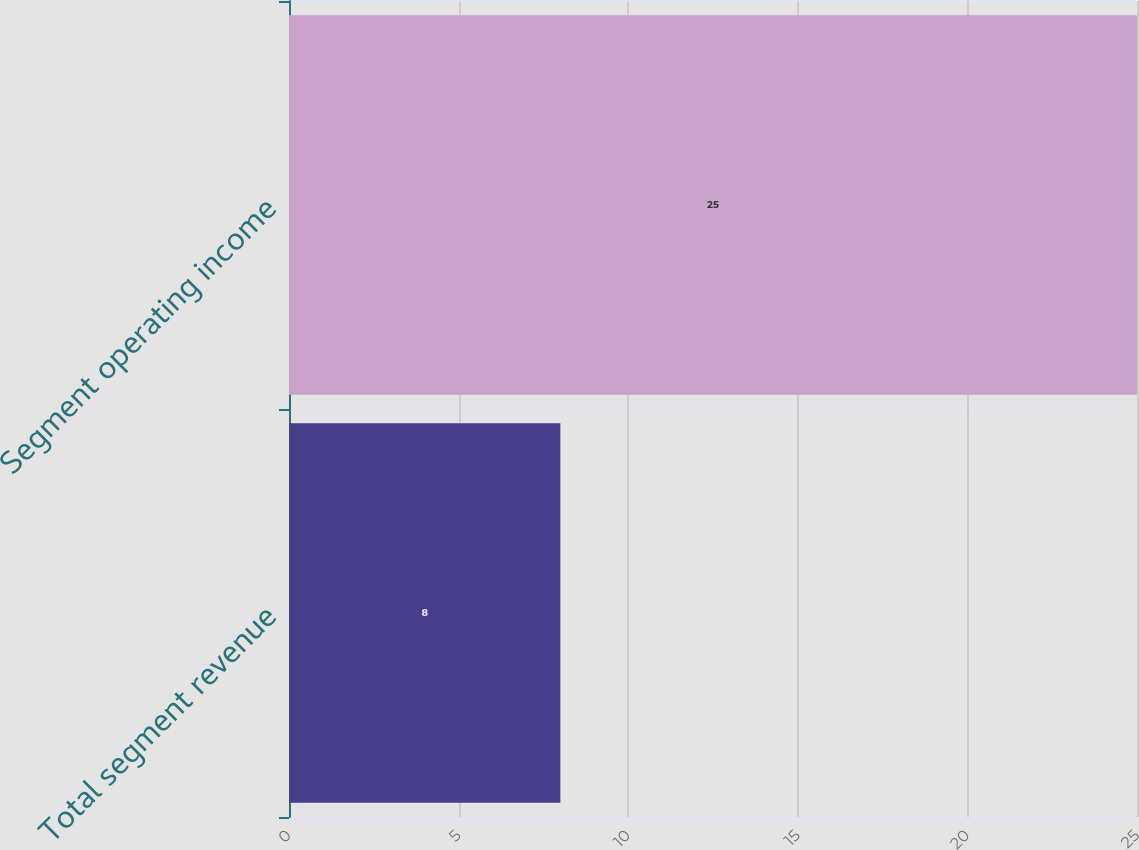Convert chart to OTSL. <chart><loc_0><loc_0><loc_500><loc_500><bar_chart><fcel>Total segment revenue<fcel>Segment operating income<nl><fcel>8<fcel>25<nl></chart> 